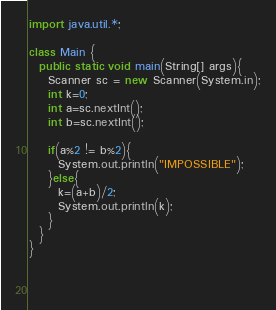<code> <loc_0><loc_0><loc_500><loc_500><_Java_>import java.util.*;

class Main {
  public static void main(String[] args){
    Scanner sc = new Scanner(System.in);
    int k=0;
    int a=sc.nextInt();
    int b=sc.nextInt();
    
    if(a%2 != b%2){
      System.out.println("IMPOSSIBLE");
    }else{
      k=(a+b)/2;
      System.out.println(k);
    }
  }
}
                   
    
  </code> 